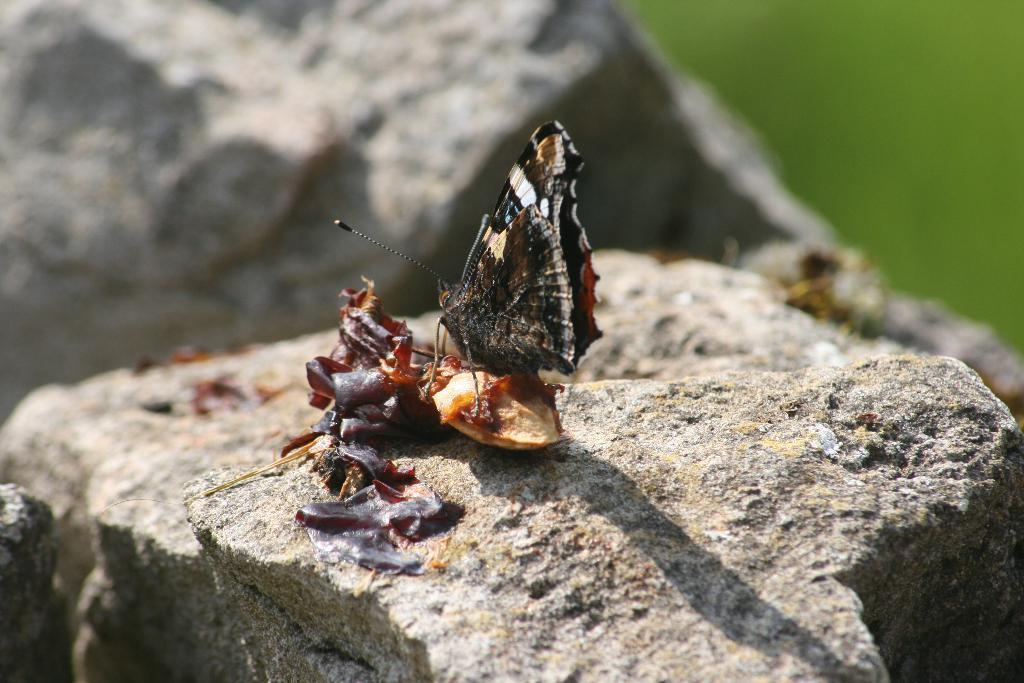What type of creature can be seen in the image? There is an insect in the image. What is the insect sitting on? The insect is on a stone surface. What type of airport is visible in the image? There is no airport present in the image; it features an insect on a stone surface. What kind of story is being told in the image? There is no story being told in the image; it simply shows an insect on a stone surface. 